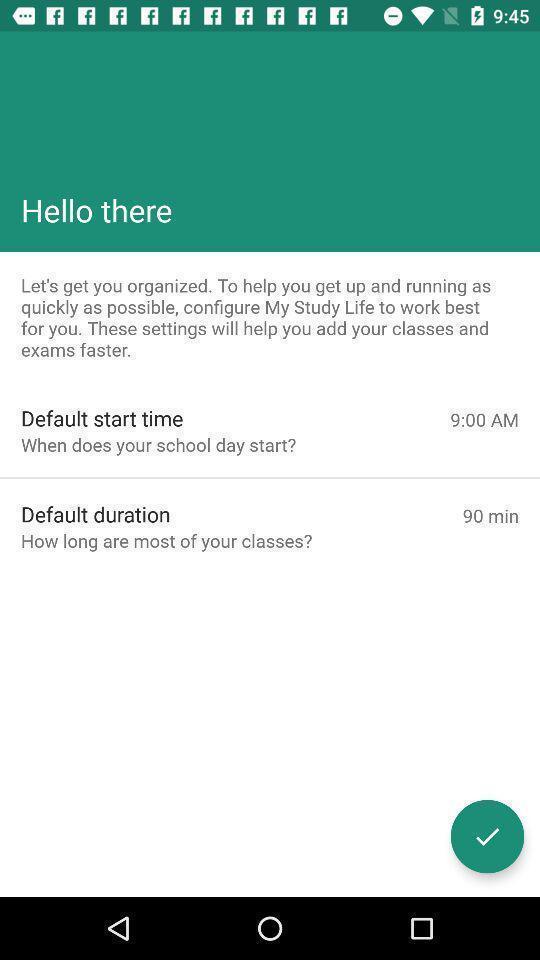Tell me about the visual elements in this screen capture. Welcome page of social app. 